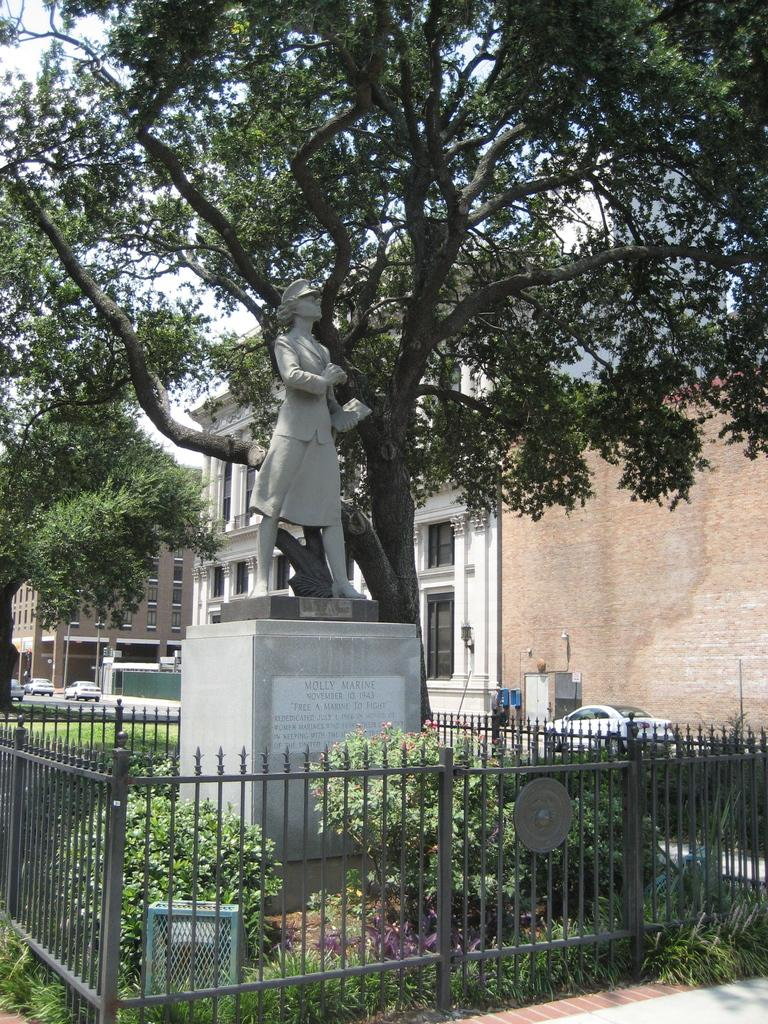<image>
Present a compact description of the photo's key features. A statue of Molly Marine is erected in a small city square. 